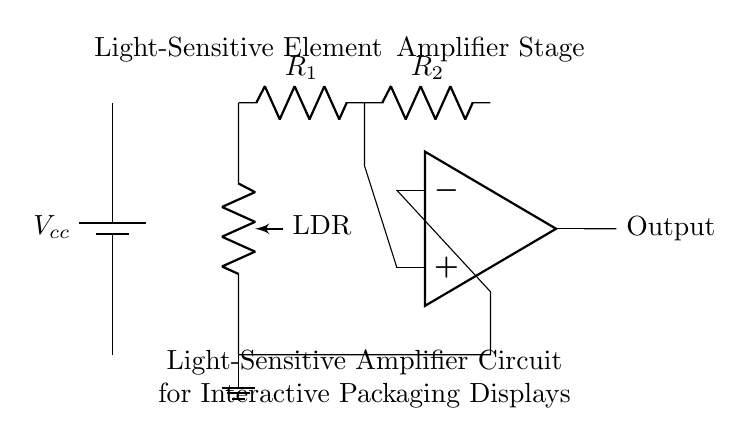What is the component labeled LDR? LDR stands for light-dependent resistor, which changes resistance based on light intensity. This component is crucial for the light-sensitive functionality of the circuit.
Answer: light-dependent resistor What voltage does the circuit use? The circuit is powered by a battery labeled Vcc, which represents the positive voltage supply. Although the exact value is not specified, it is implied that Vcc is the source voltage in this circuit.
Answer: Vcc How many resistors are in this circuit? The circuit diagram shows two resistors labeled R1 and R2 connected in series, contributing to the overall behavior of the voltage and current flow.
Answer: 2 What type of amplifier is depicted? The circuit includes an operational amplifier, which processes input signals and amplifies them based on the feedback and other components connected to it.
Answer: operational amplifier What connections come into the negative terminal of the amplifier? The negative terminal of the amplifier is connected to the output of the circuit through R2 and also to the light-dependent resistor circuit, providing the necessary feedback for amplification.
Answer: R2 and LDR What is the output of the amplifier connected to? The output of the operational amplifier is connected to a single point marked as "Output," which indicates where the amplified signal can be utilized or further processed in the circuit.
Answer: Output 